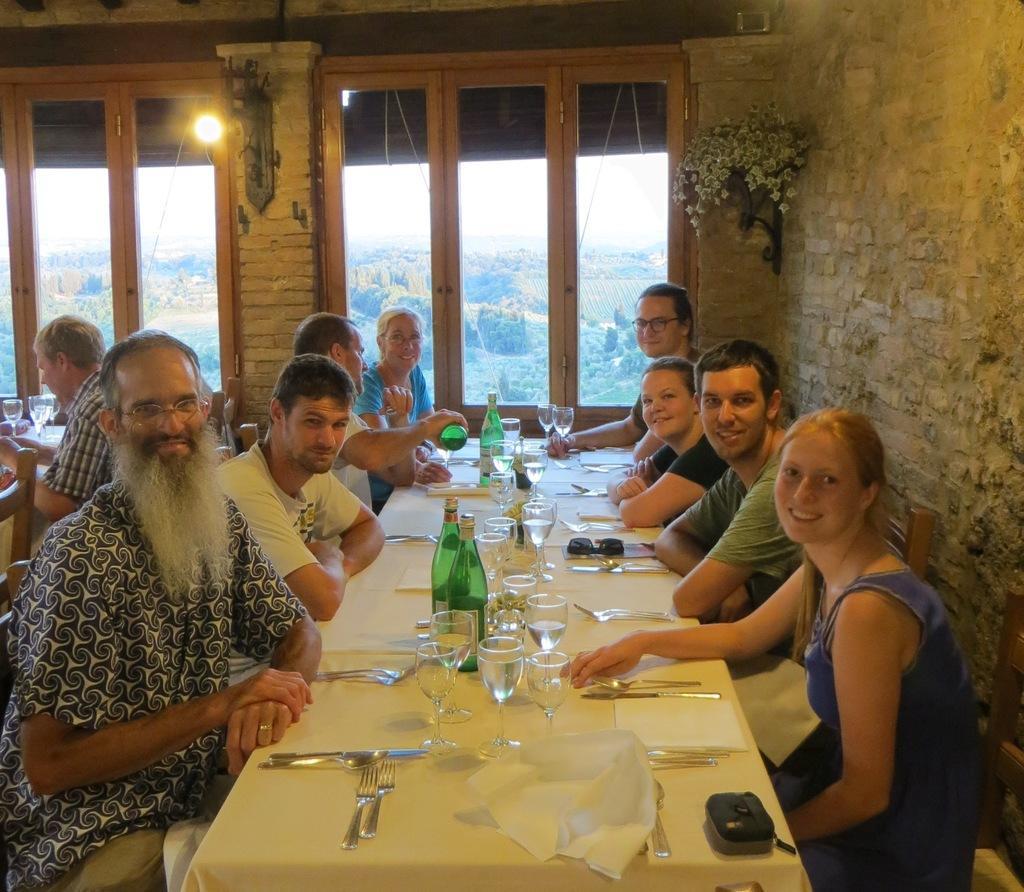How would you summarize this image in a sentence or two? This is a picture taken in a restaurant, there are a group of people sitting on a chair in front of the people there is a table covered with cloth on the table there are fork, tissue, spoon, glasses, bottle and goggle. Background of this people is a glass window and a wall on the wall there is a flower plant and a light. 